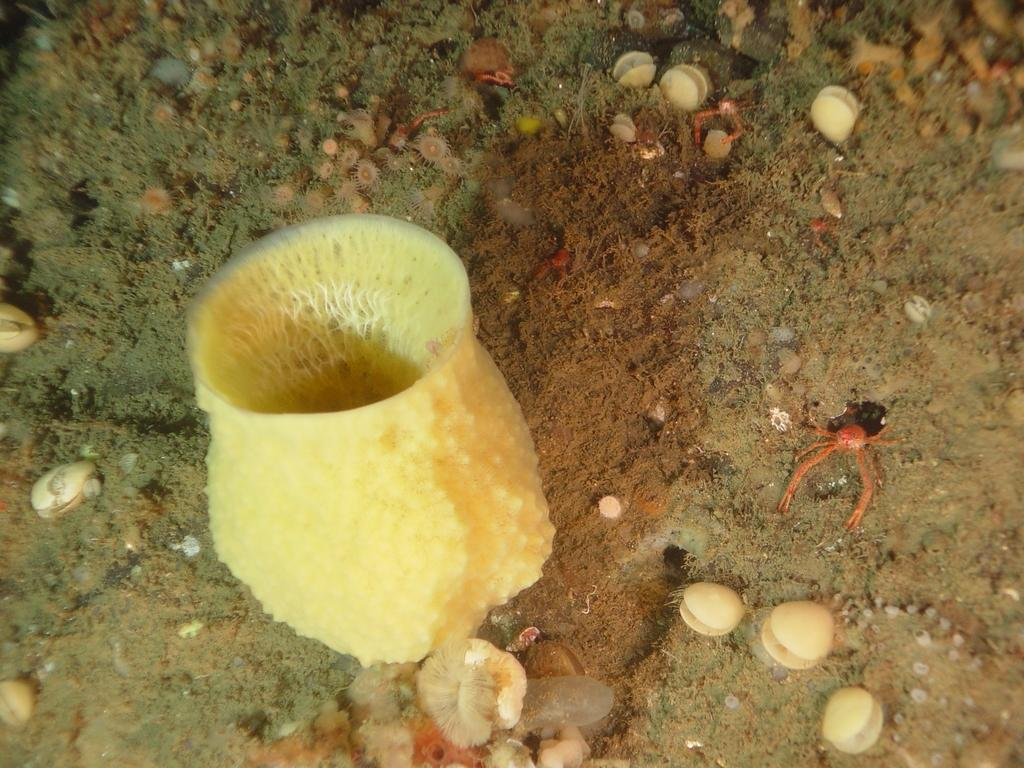What type of plants are visible in the image? There are aquatic plants in the image. What other living organisms can be seen in the image? There are aquatic animals in the image. What type of skirt is being used as a thread in the image? There is no skirt or thread present in the image; it features aquatic plants and animals. 